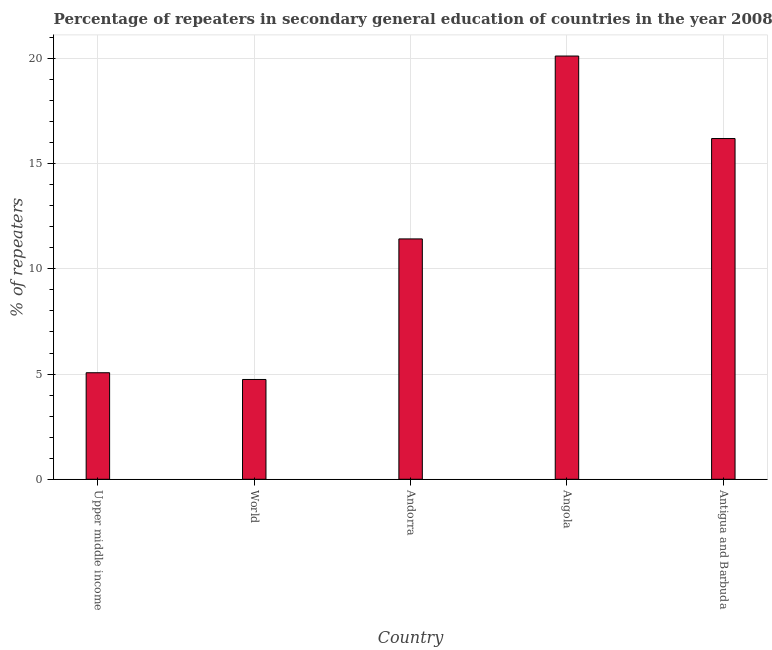What is the title of the graph?
Make the answer very short. Percentage of repeaters in secondary general education of countries in the year 2008. What is the label or title of the Y-axis?
Offer a terse response. % of repeaters. What is the percentage of repeaters in Upper middle income?
Make the answer very short. 5.06. Across all countries, what is the maximum percentage of repeaters?
Your response must be concise. 20.12. Across all countries, what is the minimum percentage of repeaters?
Ensure brevity in your answer.  4.74. In which country was the percentage of repeaters maximum?
Your answer should be very brief. Angola. What is the sum of the percentage of repeaters?
Ensure brevity in your answer.  57.54. What is the difference between the percentage of repeaters in Andorra and Antigua and Barbuda?
Provide a short and direct response. -4.77. What is the average percentage of repeaters per country?
Keep it short and to the point. 11.51. What is the median percentage of repeaters?
Your answer should be compact. 11.42. What is the ratio of the percentage of repeaters in Angola to that in World?
Your answer should be very brief. 4.24. Is the percentage of repeaters in Angola less than that in World?
Offer a terse response. No. Is the difference between the percentage of repeaters in Angola and World greater than the difference between any two countries?
Provide a short and direct response. Yes. What is the difference between the highest and the second highest percentage of repeaters?
Your response must be concise. 3.92. What is the difference between the highest and the lowest percentage of repeaters?
Make the answer very short. 15.37. How many bars are there?
Make the answer very short. 5. What is the difference between two consecutive major ticks on the Y-axis?
Offer a very short reply. 5. What is the % of repeaters of Upper middle income?
Provide a succinct answer. 5.06. What is the % of repeaters in World?
Your answer should be compact. 4.74. What is the % of repeaters in Andorra?
Make the answer very short. 11.42. What is the % of repeaters of Angola?
Make the answer very short. 20.12. What is the % of repeaters in Antigua and Barbuda?
Provide a short and direct response. 16.19. What is the difference between the % of repeaters in Upper middle income and World?
Make the answer very short. 0.32. What is the difference between the % of repeaters in Upper middle income and Andorra?
Make the answer very short. -6.36. What is the difference between the % of repeaters in Upper middle income and Angola?
Offer a very short reply. -15.05. What is the difference between the % of repeaters in Upper middle income and Antigua and Barbuda?
Make the answer very short. -11.13. What is the difference between the % of repeaters in World and Andorra?
Give a very brief answer. -6.68. What is the difference between the % of repeaters in World and Angola?
Your response must be concise. -15.37. What is the difference between the % of repeaters in World and Antigua and Barbuda?
Provide a succinct answer. -11.45. What is the difference between the % of repeaters in Andorra and Angola?
Ensure brevity in your answer.  -8.69. What is the difference between the % of repeaters in Andorra and Antigua and Barbuda?
Give a very brief answer. -4.77. What is the difference between the % of repeaters in Angola and Antigua and Barbuda?
Make the answer very short. 3.92. What is the ratio of the % of repeaters in Upper middle income to that in World?
Offer a terse response. 1.07. What is the ratio of the % of repeaters in Upper middle income to that in Andorra?
Give a very brief answer. 0.44. What is the ratio of the % of repeaters in Upper middle income to that in Angola?
Provide a short and direct response. 0.25. What is the ratio of the % of repeaters in Upper middle income to that in Antigua and Barbuda?
Offer a very short reply. 0.31. What is the ratio of the % of repeaters in World to that in Andorra?
Your answer should be compact. 0.41. What is the ratio of the % of repeaters in World to that in Angola?
Give a very brief answer. 0.24. What is the ratio of the % of repeaters in World to that in Antigua and Barbuda?
Your response must be concise. 0.29. What is the ratio of the % of repeaters in Andorra to that in Angola?
Offer a terse response. 0.57. What is the ratio of the % of repeaters in Andorra to that in Antigua and Barbuda?
Ensure brevity in your answer.  0.7. What is the ratio of the % of repeaters in Angola to that in Antigua and Barbuda?
Give a very brief answer. 1.24. 